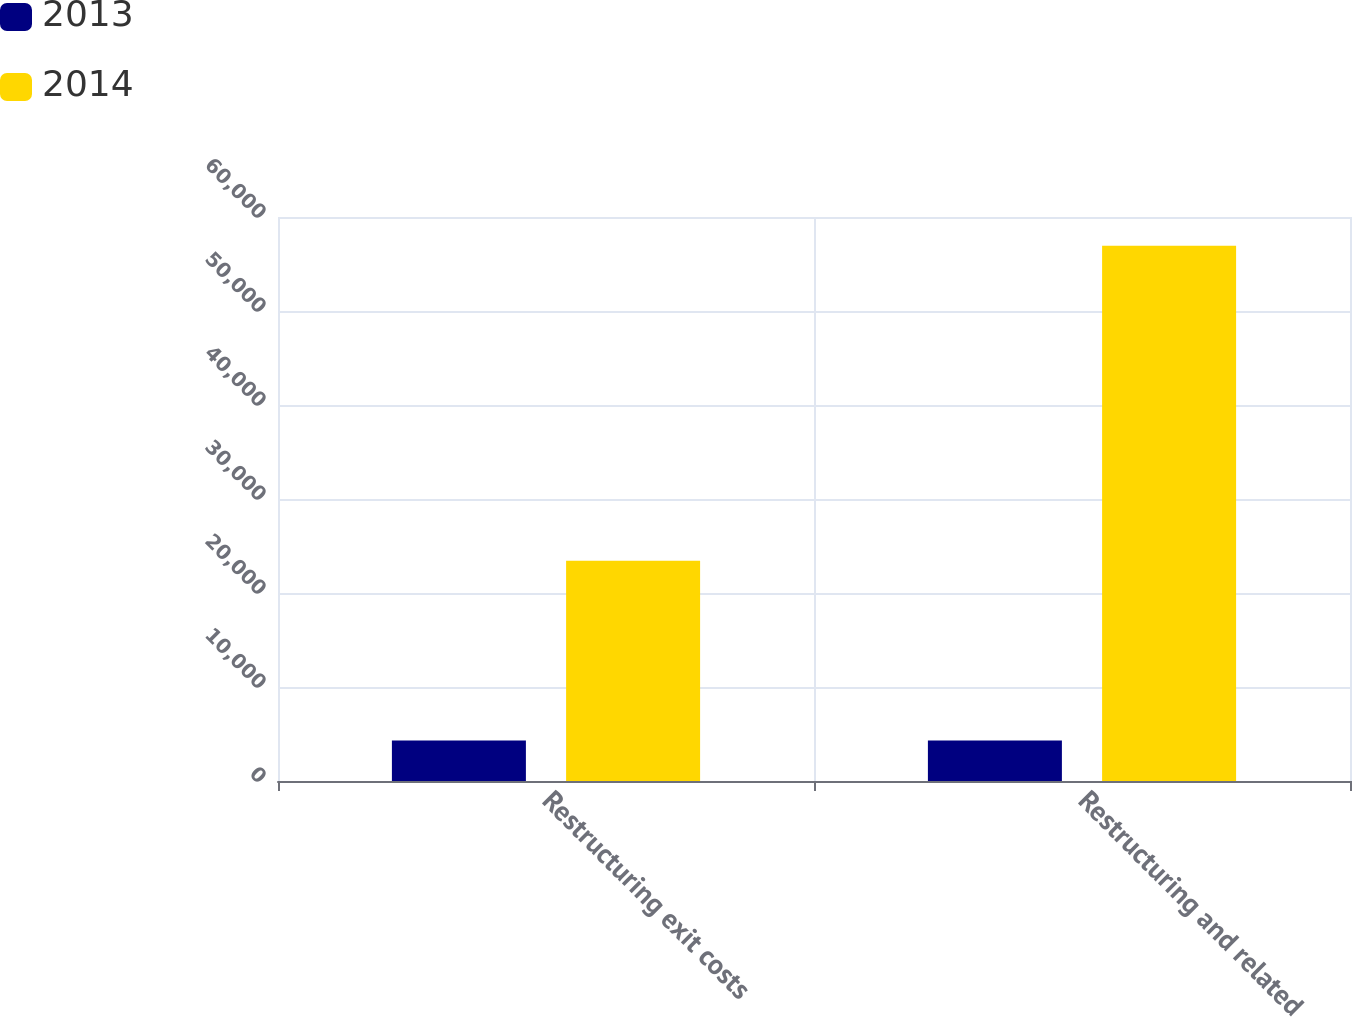Convert chart to OTSL. <chart><loc_0><loc_0><loc_500><loc_500><stacked_bar_chart><ecel><fcel>Restructuring exit costs<fcel>Restructuring and related<nl><fcel>2013<fcel>4318<fcel>4318<nl><fcel>2014<fcel>23432<fcel>56946<nl></chart> 